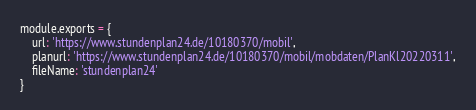Convert code to text. <code><loc_0><loc_0><loc_500><loc_500><_JavaScript_>module.exports = {
    url: 'https://www.stundenplan24.de/10180370/mobil',
    planurl: 'https://www.stundenplan24.de/10180370/mobil/mobdaten/PlanKl20220311',
    fileName: 'stundenplan24'
}</code> 